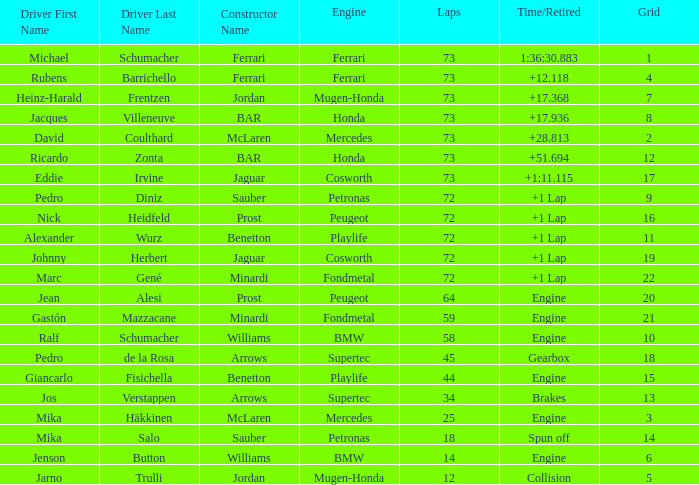How many laps did Jos Verstappen do on Grid 2? 34.0. 